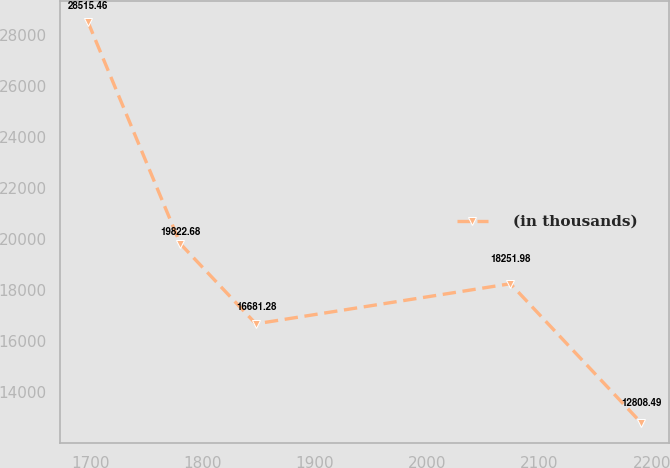Convert chart. <chart><loc_0><loc_0><loc_500><loc_500><line_chart><ecel><fcel>(in thousands)<nl><fcel>1697.81<fcel>28515.5<nl><fcel>1780.1<fcel>19822.7<nl><fcel>1847.54<fcel>16681.3<nl><fcel>2074.16<fcel>18252<nl><fcel>2190.56<fcel>12808.5<nl></chart> 